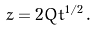Convert formula to latex. <formula><loc_0><loc_0><loc_500><loc_500>z = 2 Q t ^ { 1 / 2 } \, .</formula> 